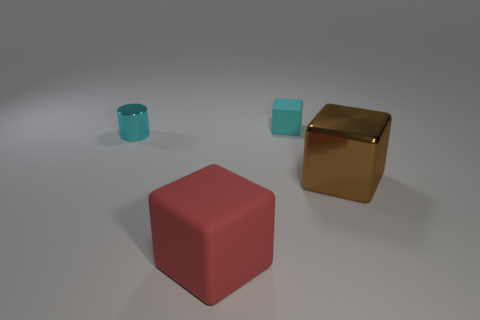What is the material of the tiny cylinder that is the same color as the tiny rubber block?
Your answer should be compact. Metal. Is the number of cylinders that are in front of the cyan cylinder less than the number of tiny cyan cylinders behind the small cyan block?
Ensure brevity in your answer.  No. What number of balls are rubber objects or big brown things?
Your answer should be very brief. 0. Do the big block on the right side of the big red matte object and the tiny thing that is to the right of the big red block have the same material?
Your answer should be compact. No. There is a shiny thing that is the same size as the cyan block; what is its shape?
Provide a succinct answer. Cylinder. What number of other things are the same color as the small rubber cube?
Provide a succinct answer. 1. What number of yellow things are small blocks or shiny cubes?
Your answer should be compact. 0. Do the big metallic object in front of the cyan metallic cylinder and the thing that is behind the tiny cyan cylinder have the same shape?
Ensure brevity in your answer.  Yes. How many other things are made of the same material as the small cube?
Your answer should be very brief. 1. Is there a small rubber block right of the block in front of the big block behind the big matte block?
Offer a very short reply. Yes. 